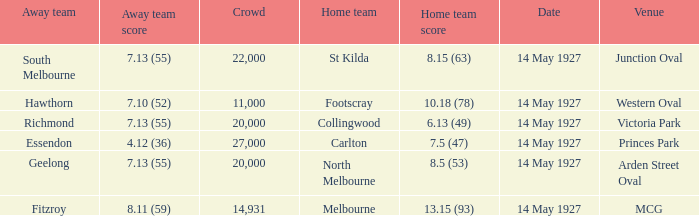Which away team had a score of 4.12 (36)? Essendon. 